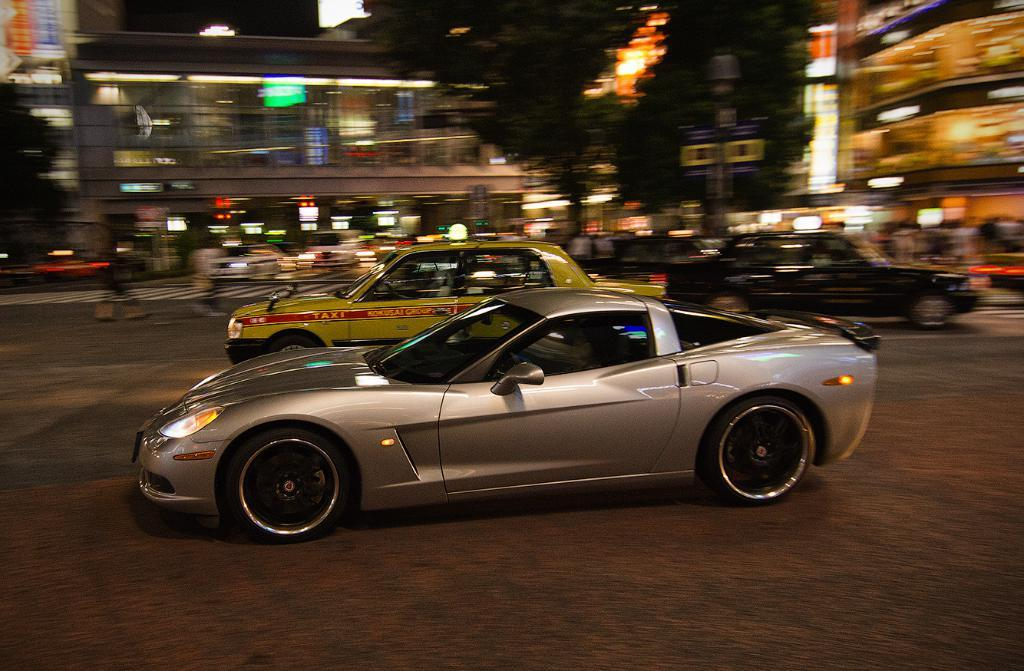What type of structures can be seen in the image? There are buildings in the image. What other natural elements are present in the image? There are trees in the image. Are there any vehicles visible in the image? Yes, there are cars in the image. What type of illumination can be seen in the image? There are lights visible in the image. What book is being read in the library in the image? There is no library or book present in the image. What day of the week is it in the image? The day of the week cannot be determined from the image. 